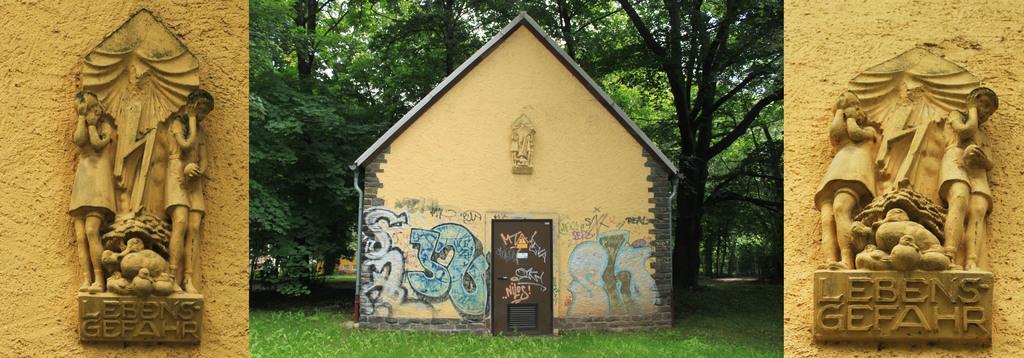Can you describe this image briefly? In this picture we can see a house and in front of the house there is grass and behind the house there are trees and on the left and right side of the house there are sculptures. 